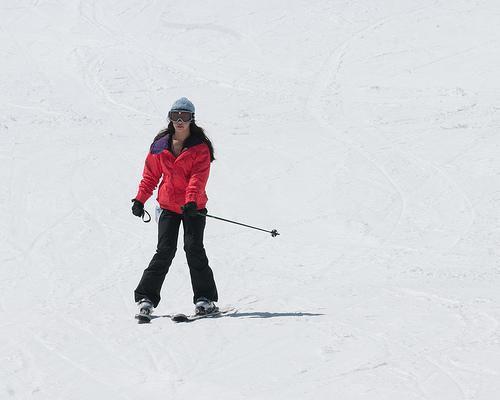How many women are there?
Give a very brief answer. 1. 